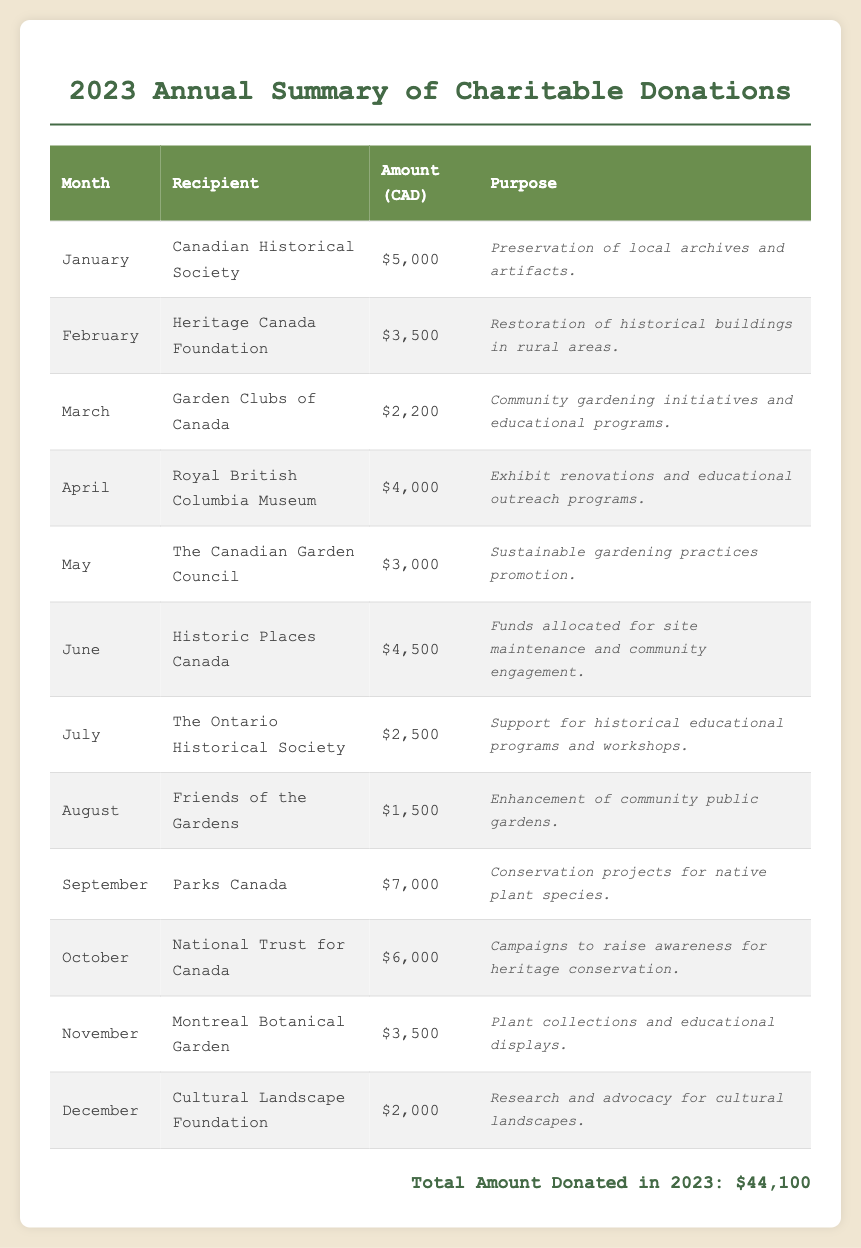What is the total amount donated in 2023? The total amount donated is listed at the end of the document, which sums all the individual donations.
Answer: $44,100 Which organization received the highest amount in September? The organization listed for September and its corresponding amount is Parks Canada, which received $7,000.
Answer: Parks Canada How much was donated to the Montreal Botanical Garden in November? The document explicitly states the amount donated to the Montreal Botanical Garden in November is $3,500.
Answer: $3,500 What purpose is associated with the donations to the Heritage Canada Foundation in February? The purpose listed for the Heritage Canada Foundation’s donation in February is restoration of historical buildings in rural areas.
Answer: Restoration of historical buildings in rural areas In which month was the lowest donation amount made and what was that amount? The lowest donation amount is in August, as indicated for Friends of the Gardens with an amount of $1,500.
Answer: $1,500 How many donations were made to gardening-related organizations in 2023? The document lists two organizations associated with gardening: Garden Clubs of Canada and The Canadian Garden Council.
Answer: 2 Which organization received donations in both April and October? The organization listed in both months is National Trust for Canada.
Answer: National Trust for Canada What is the purpose of the donation made to Historic Places Canada in June? The donation purpose provided for Historic Places Canada in June is for site maintenance and community engagement.
Answer: Site maintenance and community engagement 